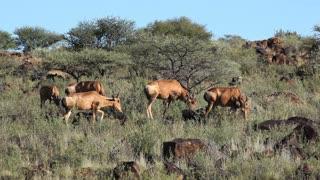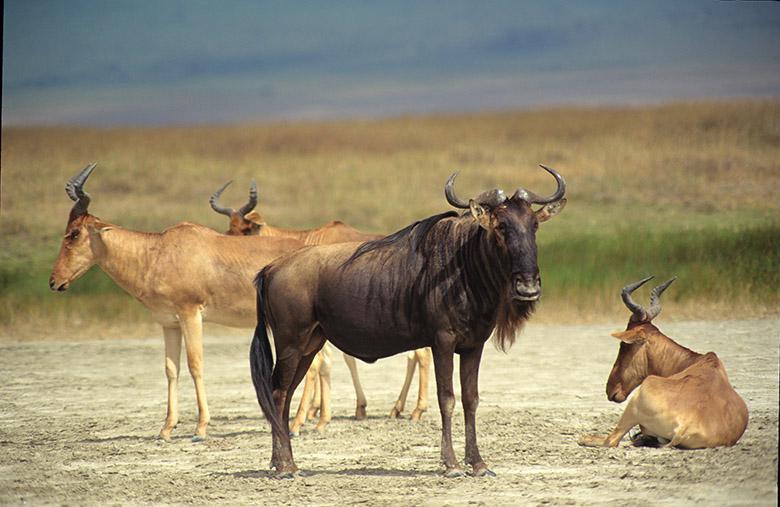The first image is the image on the left, the second image is the image on the right. For the images displayed, is the sentence "There are a number of zebras among the other types of animals present." factually correct? Answer yes or no. No. The first image is the image on the left, the second image is the image on the right. Analyze the images presented: Is the assertion "Zebras and antelopes are mingling together." valid? Answer yes or no. No. 